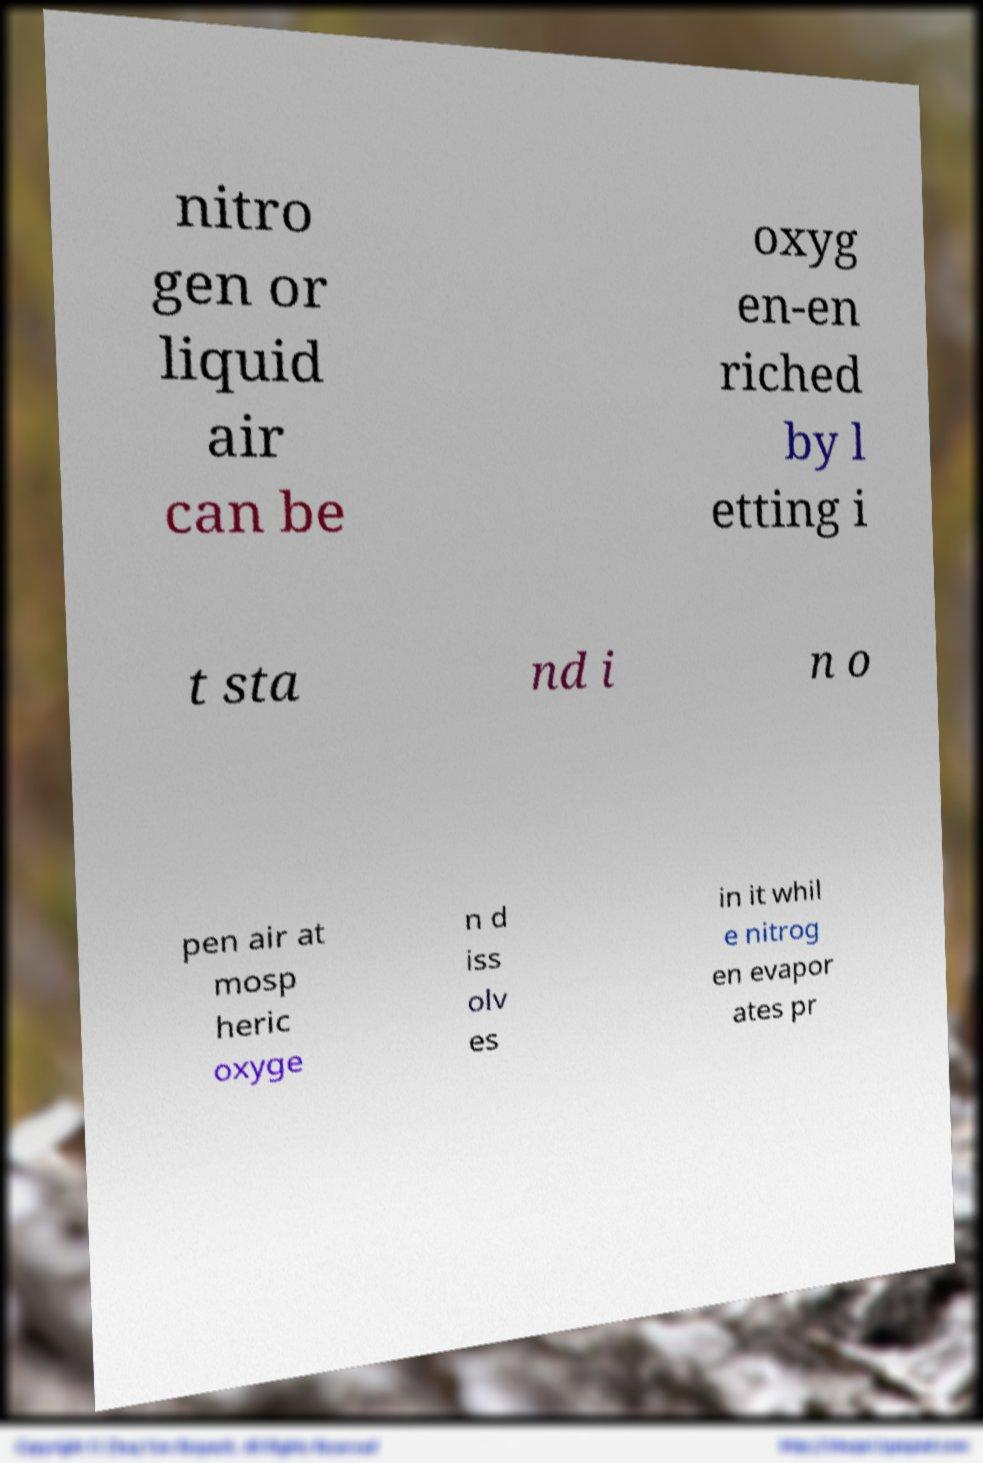Can you read and provide the text displayed in the image?This photo seems to have some interesting text. Can you extract and type it out for me? nitro gen or liquid air can be oxyg en-en riched by l etting i t sta nd i n o pen air at mosp heric oxyge n d iss olv es in it whil e nitrog en evapor ates pr 